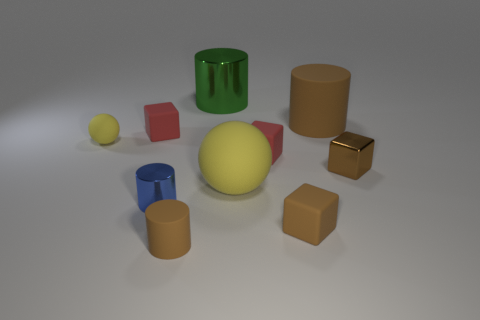The other sphere that is the same color as the big rubber sphere is what size?
Your answer should be very brief. Small. What shape is the matte thing that is the same color as the large ball?
Ensure brevity in your answer.  Sphere. How many tiny blue rubber cylinders are there?
Provide a succinct answer. 0. There is a yellow rubber object that is on the right side of the big green shiny cylinder; what is its size?
Make the answer very short. Large. Do the blue object and the green shiny object have the same size?
Your answer should be compact. No. What number of things are small brown metallic things or things behind the tiny matte ball?
Keep it short and to the point. 4. What is the material of the big yellow thing?
Provide a short and direct response. Rubber. Are there any other things of the same color as the large ball?
Ensure brevity in your answer.  Yes. Is the small brown shiny thing the same shape as the big brown thing?
Ensure brevity in your answer.  No. There is a brown cylinder behind the red matte cube that is behind the matte sphere to the left of the small blue object; what size is it?
Make the answer very short. Large. 